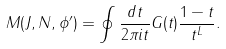<formula> <loc_0><loc_0><loc_500><loc_500>M ( J , N , \phi ^ { \prime } ) = \oint \frac { d t } { 2 \pi i t } G ( t ) \frac { 1 - t } { t ^ { L } } .</formula> 